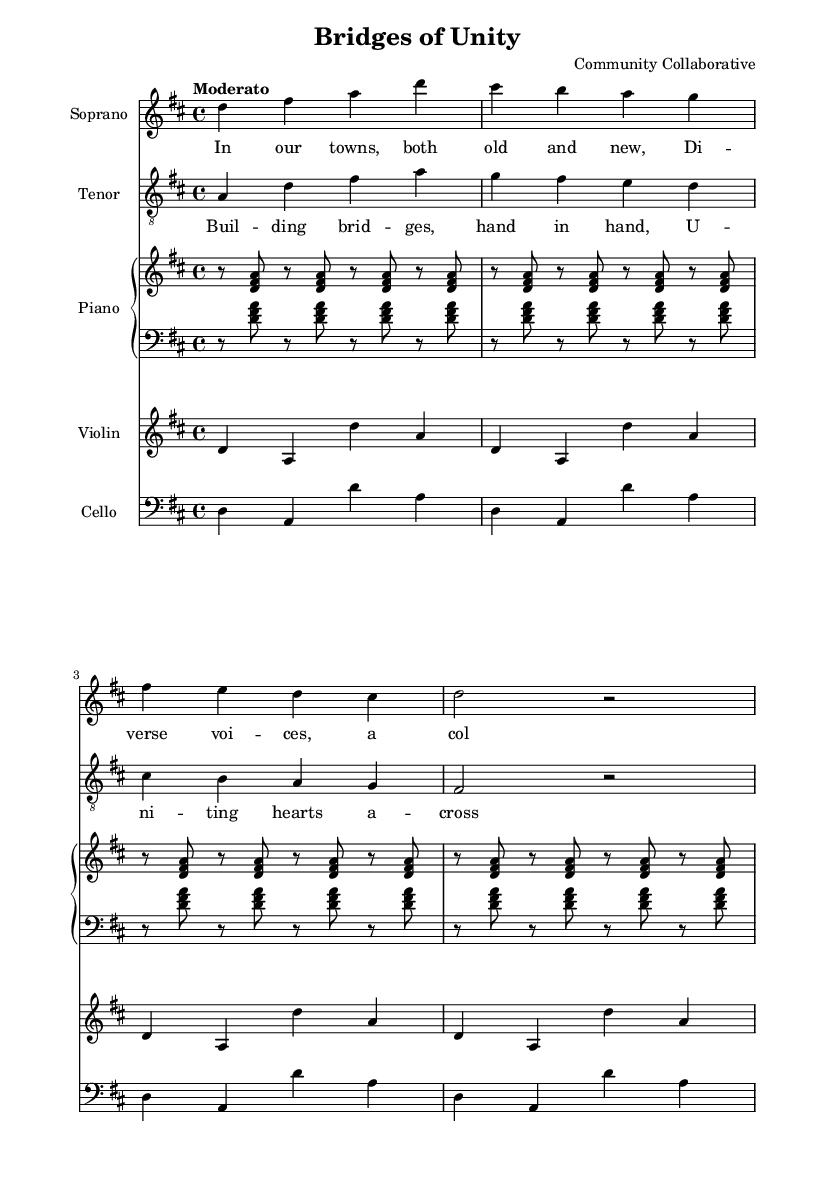What is the key signature of this music? The key signature is indicated by the sharps or flats at the beginning of the staff. In this piece, the key signature has two sharps, which corresponds to D major.
Answer: D major What is the time signature of this music? The time signature is displayed as a fraction at the beginning of the staff. It shows that there are four beats in each measure and a quarter note gets one beat.
Answer: 4/4 What is the tempo marking of this piece? The tempo marking is written above the staff, indicating the speed of the music. In this case, it is marked as "Moderato," suggesting a moderate pace.
Answer: Moderato How many measures are there in the soprano part? To determine this, count the measures in the soprano line, which can be visually separated by vertical lines on the staff. There are a total of four measures.
Answer: 4 In what genre is this piece classified? The title and the context within which it is presented indicate that it falls under the genre of opera, specifically focused on community and social issues.
Answer: Opera What is the lyrical theme of the chorus? The lyrics in the chorus mention "building bridges" and "uniting hearts," suggesting themes of connectivity and community unity.
Answer: Unity How many instruments are featured in this piece? By counting the distinct staff sections in the music sheet, we can determine that there are five instrumental parts: Soprano, Tenor, Piano, Violin, and Cello.
Answer: 5 